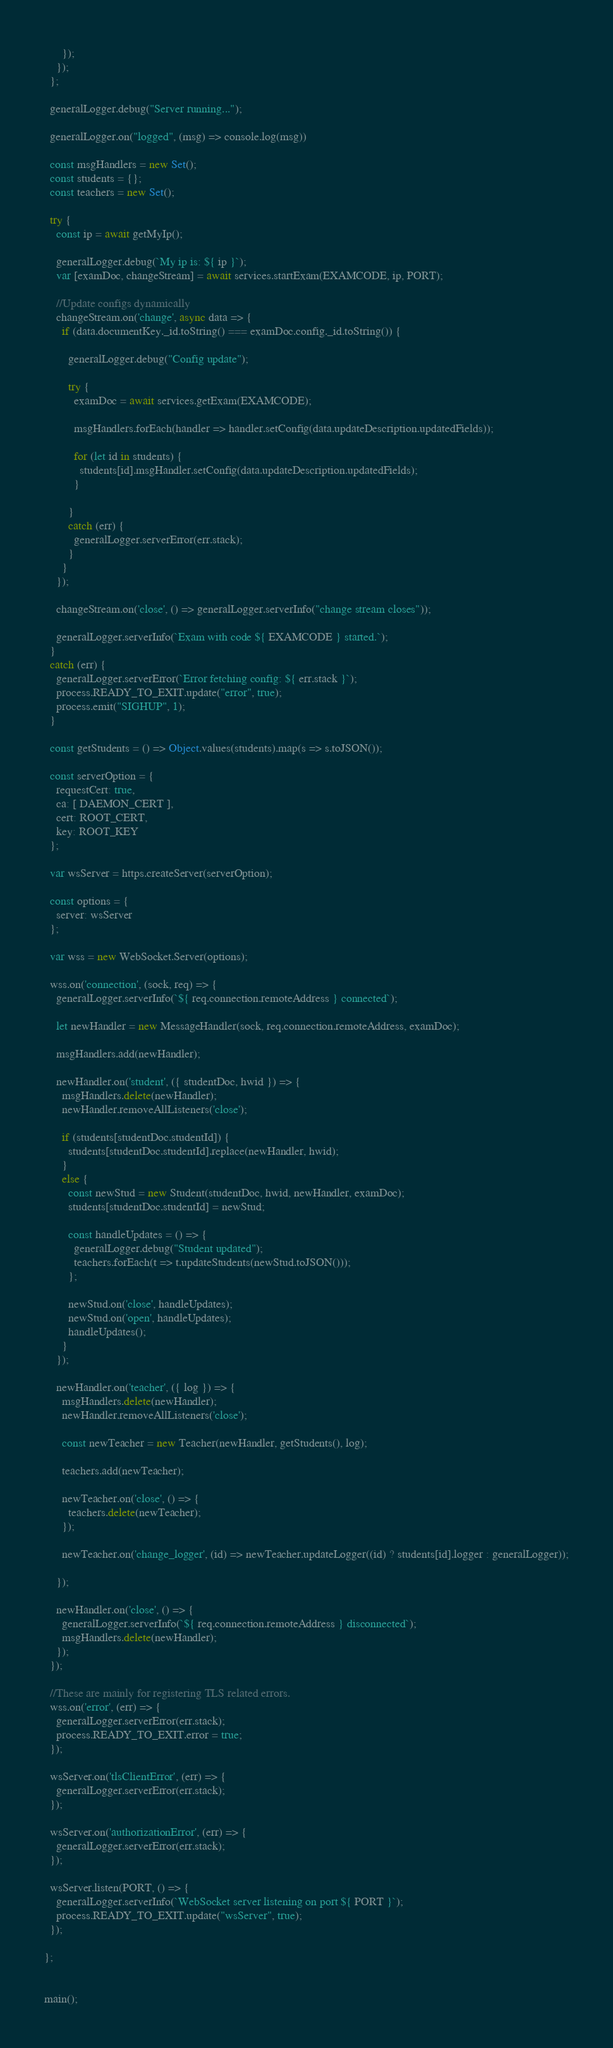<code> <loc_0><loc_0><loc_500><loc_500><_JavaScript_>      });
    });
  };

  generalLogger.debug("Server running...");

  generalLogger.on("logged", (msg) => console.log(msg))

  const msgHandlers = new Set();
  const students = {};
  const teachers = new Set();

  try {
    const ip = await getMyIp();
  
    generalLogger.debug(`My ip is: ${ ip }`);
    var [examDoc, changeStream] = await services.startExam(EXAMCODE, ip, PORT);
    
    //Update configs dynamically
    changeStream.on('change', async data => {
      if (data.documentKey._id.toString() === examDoc.config._id.toString()) {

        generalLogger.debug("Config update");

        try {
          examDoc = await services.getExam(EXAMCODE);
          
          msgHandlers.forEach(handler => handler.setConfig(data.updateDescription.updatedFields));
          
          for (let id in students) {
            students[id].msgHandler.setConfig(data.updateDescription.updatedFields);
          }

        }
        catch (err) {
          generalLogger.serverError(err.stack);
        }
      }
    });

    changeStream.on('close', () => generalLogger.serverInfo("change stream closes"));

    generalLogger.serverInfo(`Exam with code ${ EXAMCODE } started.`);
  }
  catch (err) {
    generalLogger.serverError(`Error fetching config: ${ err.stack }`);
    process.READY_TO_EXIT.update("error", true);
    process.emit("SIGHUP", 1);
  } 

  const getStudents = () => Object.values(students).map(s => s.toJSON());

  const serverOption = {
    requestCert: true,
    ca: [ DAEMON_CERT ],
    cert: ROOT_CERT,
    key: ROOT_KEY
  };

  var wsServer = https.createServer(serverOption);

  const options = {
    server: wsServer
  };

  var wss = new WebSocket.Server(options);

  wss.on('connection', (sock, req) => {
    generalLogger.serverInfo(`${ req.connection.remoteAddress } connected`);

    let newHandler = new MessageHandler(sock, req.connection.remoteAddress, examDoc);

    msgHandlers.add(newHandler);

    newHandler.on('student', ({ studentDoc, hwid }) => {
      msgHandlers.delete(newHandler);
      newHandler.removeAllListeners('close');

      if (students[studentDoc.studentId]) {
        students[studentDoc.studentId].replace(newHandler, hwid);
      }
      else {
        const newStud = new Student(studentDoc, hwid, newHandler, examDoc);
        students[studentDoc.studentId] = newStud;

        const handleUpdates = () => {
          generalLogger.debug("Student updated");
          teachers.forEach(t => t.updateStudents(newStud.toJSON()));
        };

        newStud.on('close', handleUpdates);
        newStud.on('open', handleUpdates);
        handleUpdates();
      }
    });

    newHandler.on('teacher', ({ log }) => {
      msgHandlers.delete(newHandler);
      newHandler.removeAllListeners('close');

      const newTeacher = new Teacher(newHandler, getStudents(), log);

      teachers.add(newTeacher);

      newTeacher.on('close', () => {
        teachers.delete(newTeacher);
      });

      newTeacher.on('change_logger', (id) => newTeacher.updateLogger((id) ? students[id].logger : generalLogger));

    });

    newHandler.on('close', () => {
      generalLogger.serverInfo(`${ req.connection.remoteAddress } disconnected`);
      msgHandlers.delete(newHandler);
    });
  });

  //These are mainly for registering TLS related errors.
  wss.on('error', (err) => {
    generalLogger.serverError(err.stack);
    process.READY_TO_EXIT.error = true;
  });

  wsServer.on('tlsClientError', (err) => {
    generalLogger.serverError(err.stack);
  });

  wsServer.on('authorizationError', (err) => {
    generalLogger.serverError(err.stack);
  });

  wsServer.listen(PORT, () => {
    generalLogger.serverInfo(`WebSocket server listening on port ${ PORT }`);
    process.READY_TO_EXIT.update("wsServer", true);
  });

};


main();</code> 